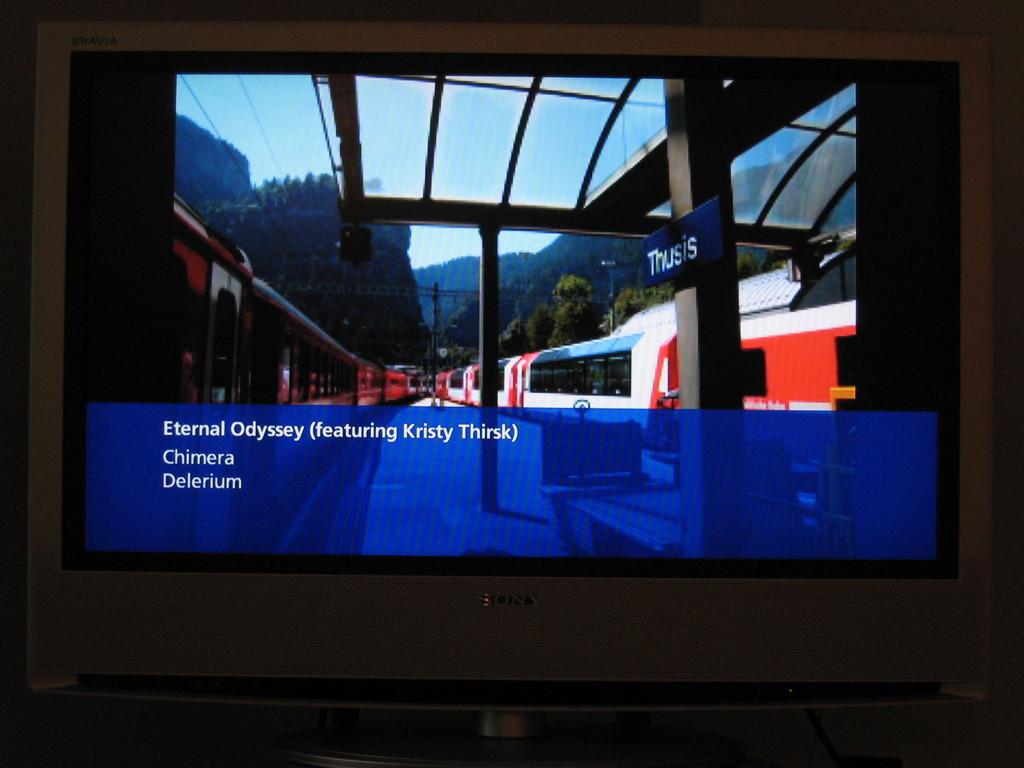Who is featured?
Offer a terse response. Kristy thirsk. What song name is shown?
Keep it short and to the point. Eternal odyssey. 